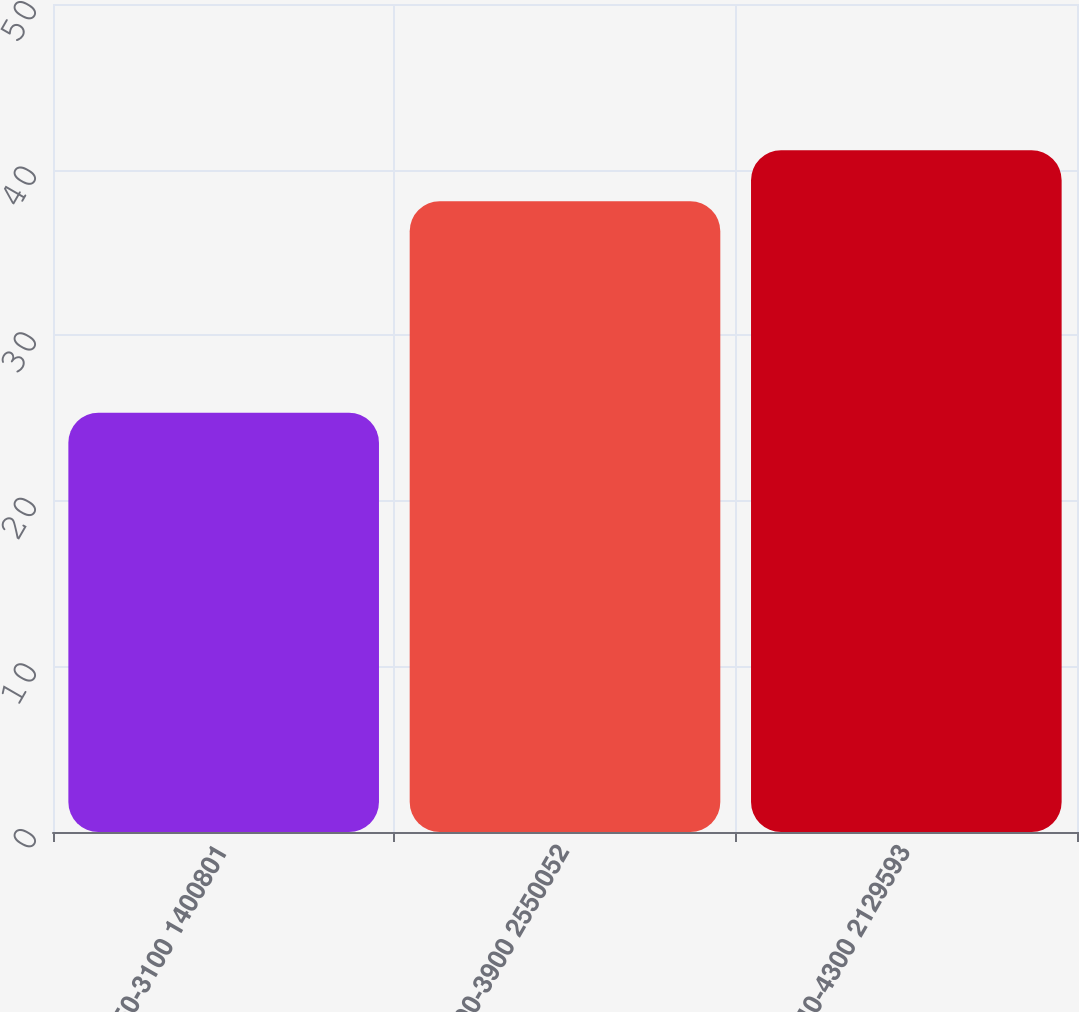<chart> <loc_0><loc_0><loc_500><loc_500><bar_chart><fcel>2450-3100 1400801<fcel>3300-3900 2550052<fcel>3940-4300 2129593<nl><fcel>25.32<fcel>38.09<fcel>41.17<nl></chart> 